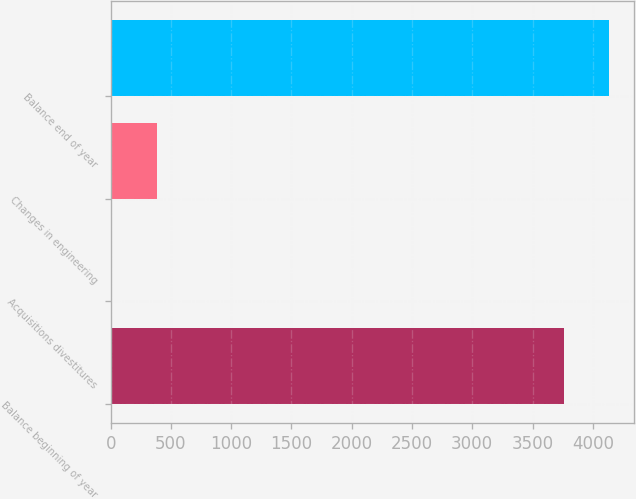<chart> <loc_0><loc_0><loc_500><loc_500><bar_chart><fcel>Balance beginning of year<fcel>Acquisitions divestitures<fcel>Changes in engineering<fcel>Balance end of year<nl><fcel>3760<fcel>5<fcel>383.2<fcel>4138.2<nl></chart> 